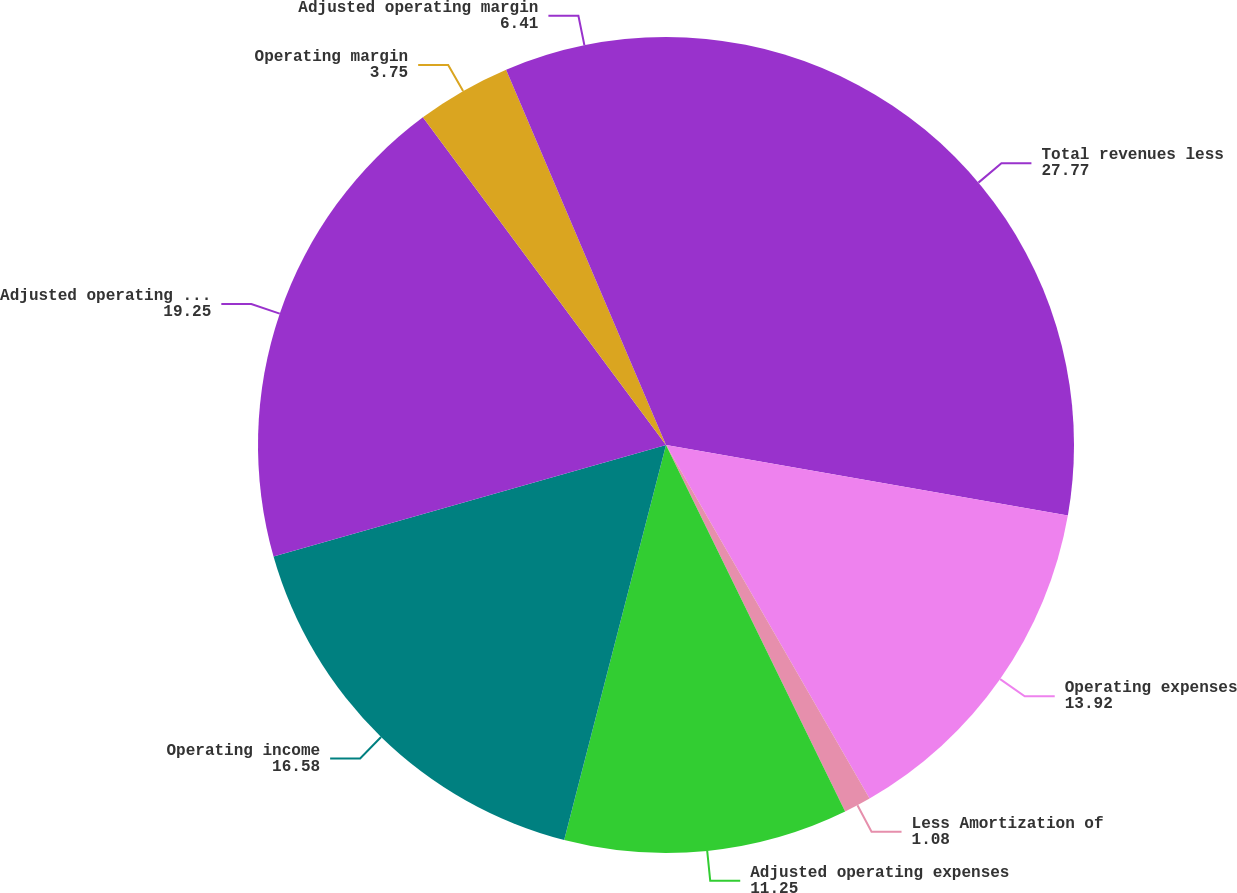Convert chart to OTSL. <chart><loc_0><loc_0><loc_500><loc_500><pie_chart><fcel>Total revenues less<fcel>Operating expenses<fcel>Less Amortization of<fcel>Adjusted operating expenses<fcel>Operating income<fcel>Adjusted operating income<fcel>Operating margin<fcel>Adjusted operating margin<nl><fcel>27.77%<fcel>13.92%<fcel>1.08%<fcel>11.25%<fcel>16.58%<fcel>19.25%<fcel>3.75%<fcel>6.41%<nl></chart> 